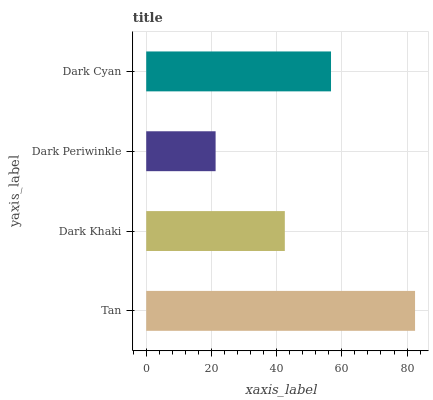Is Dark Periwinkle the minimum?
Answer yes or no. Yes. Is Tan the maximum?
Answer yes or no. Yes. Is Dark Khaki the minimum?
Answer yes or no. No. Is Dark Khaki the maximum?
Answer yes or no. No. Is Tan greater than Dark Khaki?
Answer yes or no. Yes. Is Dark Khaki less than Tan?
Answer yes or no. Yes. Is Dark Khaki greater than Tan?
Answer yes or no. No. Is Tan less than Dark Khaki?
Answer yes or no. No. Is Dark Cyan the high median?
Answer yes or no. Yes. Is Dark Khaki the low median?
Answer yes or no. Yes. Is Dark Periwinkle the high median?
Answer yes or no. No. Is Tan the low median?
Answer yes or no. No. 